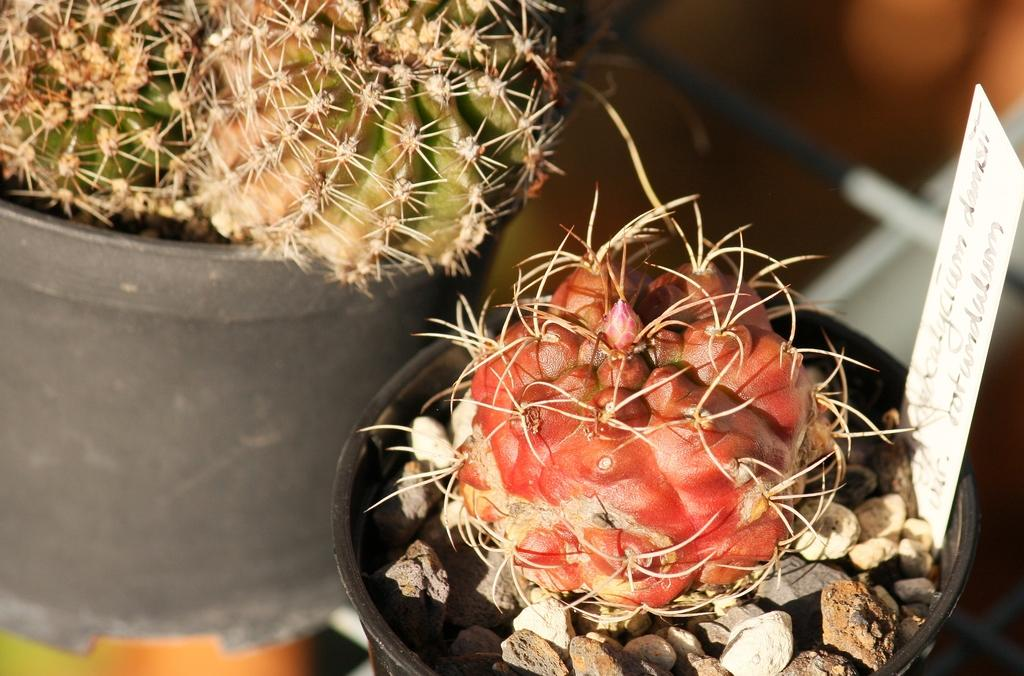How many pots are visible in the image? There are two pots in the image. What type of plants are in the pots? There are cactus plants in the pots. Can you describe any additional features of the pots? At least one of the pots has a label on it. What type of owl can be seen perched on the cactus plants in the image? There is no owl present in the image; it features two pots with cactus plants and a labeled pot. 